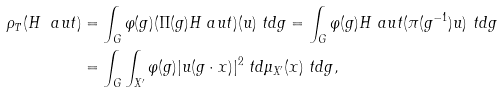<formula> <loc_0><loc_0><loc_500><loc_500>\rho _ { T } ( H ^ { \ } a u t ) & = \int _ { G } \varphi ( g ) ( \Pi ( g ) H ^ { \ } a u t ) ( u ) \ t d g = \int _ { G } \varphi ( g ) H ^ { \ } a u t ( \pi ( g ^ { - 1 } ) u ) \ t d g \\ & = \int _ { G } \int _ { X ^ { \prime } } \varphi ( g ) | u ( g \cdot x ) | ^ { 2 } \ t d \mu _ { X ^ { \prime } } ( x ) \ t d g ,</formula> 